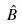<formula> <loc_0><loc_0><loc_500><loc_500>\hat { B }</formula> 